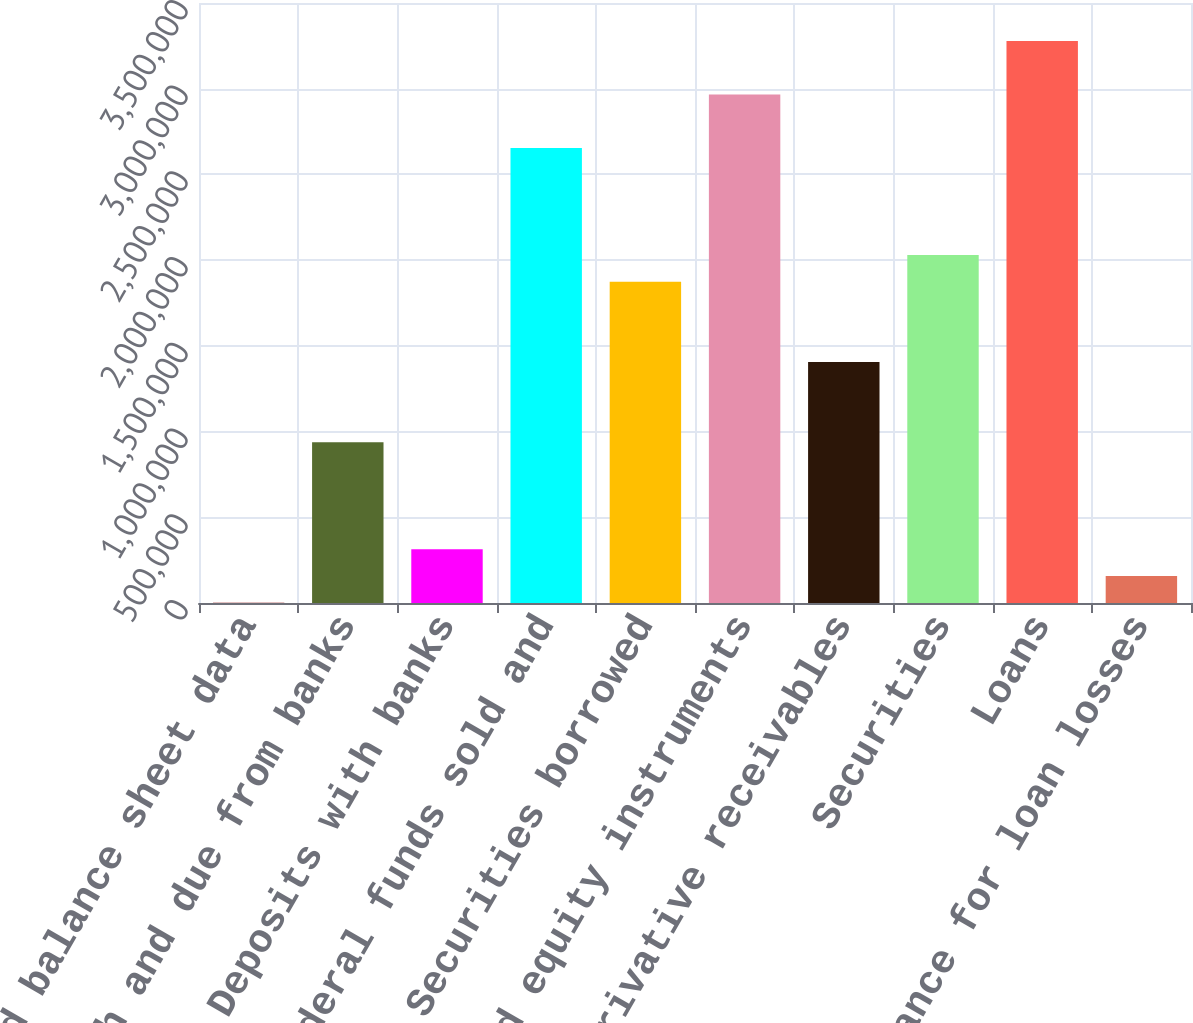<chart> <loc_0><loc_0><loc_500><loc_500><bar_chart><fcel>Selected balance sheet data<fcel>Cash and due from banks<fcel>Deposits with banks<fcel>Federal funds sold and<fcel>Securities borrowed<fcel>Debt and equity instruments<fcel>Derivative receivables<fcel>Securities<fcel>Loans<fcel>Allowance for loan losses<nl><fcel>2007<fcel>938091<fcel>314035<fcel>2.65424e+06<fcel>1.87418e+06<fcel>2.96627e+06<fcel>1.40613e+06<fcel>2.03019e+06<fcel>3.2783e+06<fcel>158021<nl></chart> 